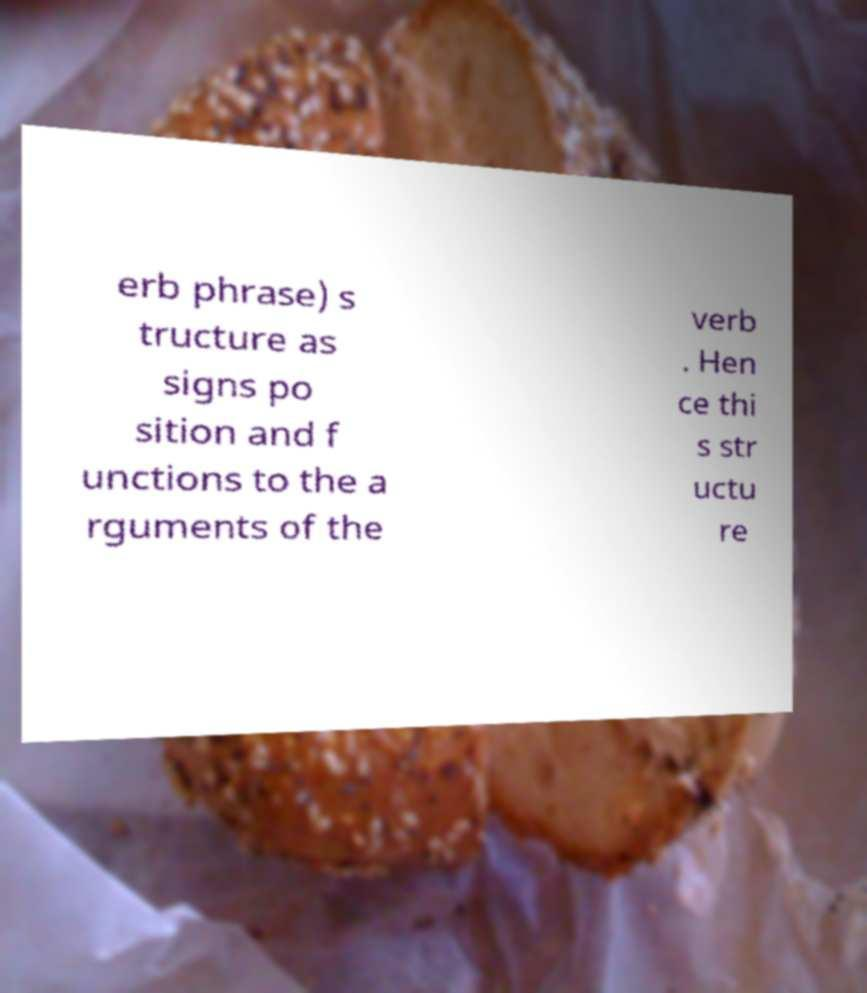What messages or text are displayed in this image? I need them in a readable, typed format. erb phrase) s tructure as signs po sition and f unctions to the a rguments of the verb . Hen ce thi s str uctu re 